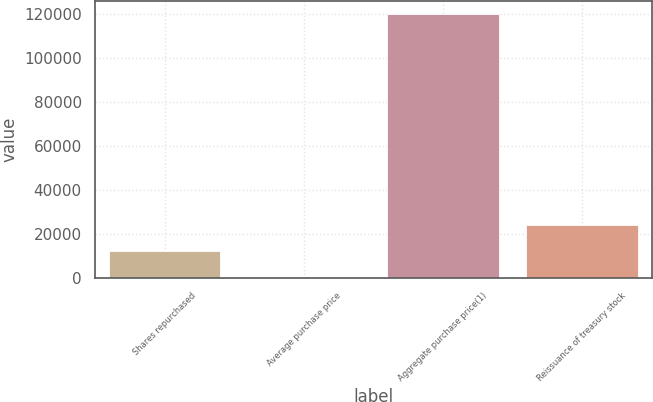Convert chart. <chart><loc_0><loc_0><loc_500><loc_500><bar_chart><fcel>Shares repurchased<fcel>Average purchase price<fcel>Aggregate purchase price(1)<fcel>Reissuance of treasury stock<nl><fcel>12009.5<fcel>38.72<fcel>119747<fcel>23980.4<nl></chart> 